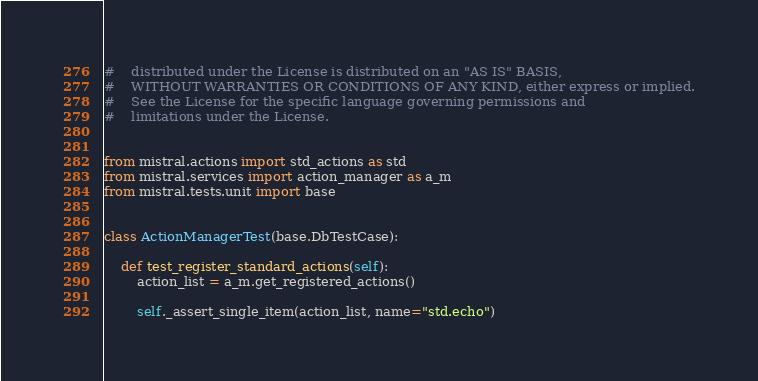Convert code to text. <code><loc_0><loc_0><loc_500><loc_500><_Python_>#    distributed under the License is distributed on an "AS IS" BASIS,
#    WITHOUT WARRANTIES OR CONDITIONS OF ANY KIND, either express or implied.
#    See the License for the specific language governing permissions and
#    limitations under the License.


from mistral.actions import std_actions as std
from mistral.services import action_manager as a_m
from mistral.tests.unit import base


class ActionManagerTest(base.DbTestCase):

    def test_register_standard_actions(self):
        action_list = a_m.get_registered_actions()

        self._assert_single_item(action_list, name="std.echo")</code> 